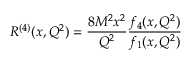Convert formula to latex. <formula><loc_0><loc_0><loc_500><loc_500>R ^ { ( 4 ) } ( x , Q ^ { 2 } ) = \frac { 8 M ^ { 2 } x ^ { 2 } } { Q ^ { 2 } } \frac { f _ { 4 } ( x , Q ^ { 2 } ) } { f _ { 1 } ( x , Q ^ { 2 } ) }</formula> 